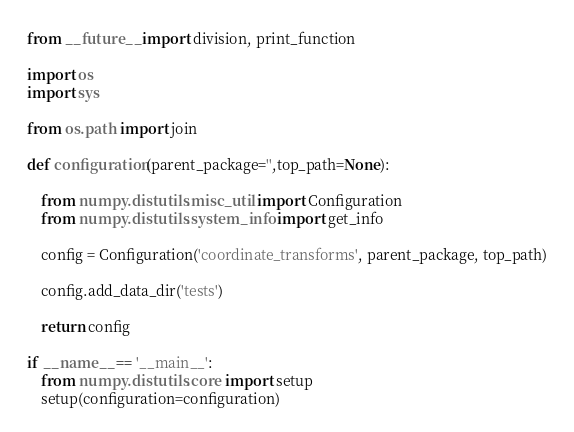Convert code to text. <code><loc_0><loc_0><loc_500><loc_500><_Python_>from __future__ import division, print_function

import os
import sys

from os.path import join

def configuration(parent_package='',top_path=None):
    
    from numpy.distutils.misc_util import Configuration
    from numpy.distutils.system_info import get_info
    
    config = Configuration('coordinate_transforms', parent_package, top_path)

    config.add_data_dir('tests')

    return config
    
if __name__ == '__main__':
    from numpy.distutils.core import setup
    setup(configuration=configuration)
</code> 